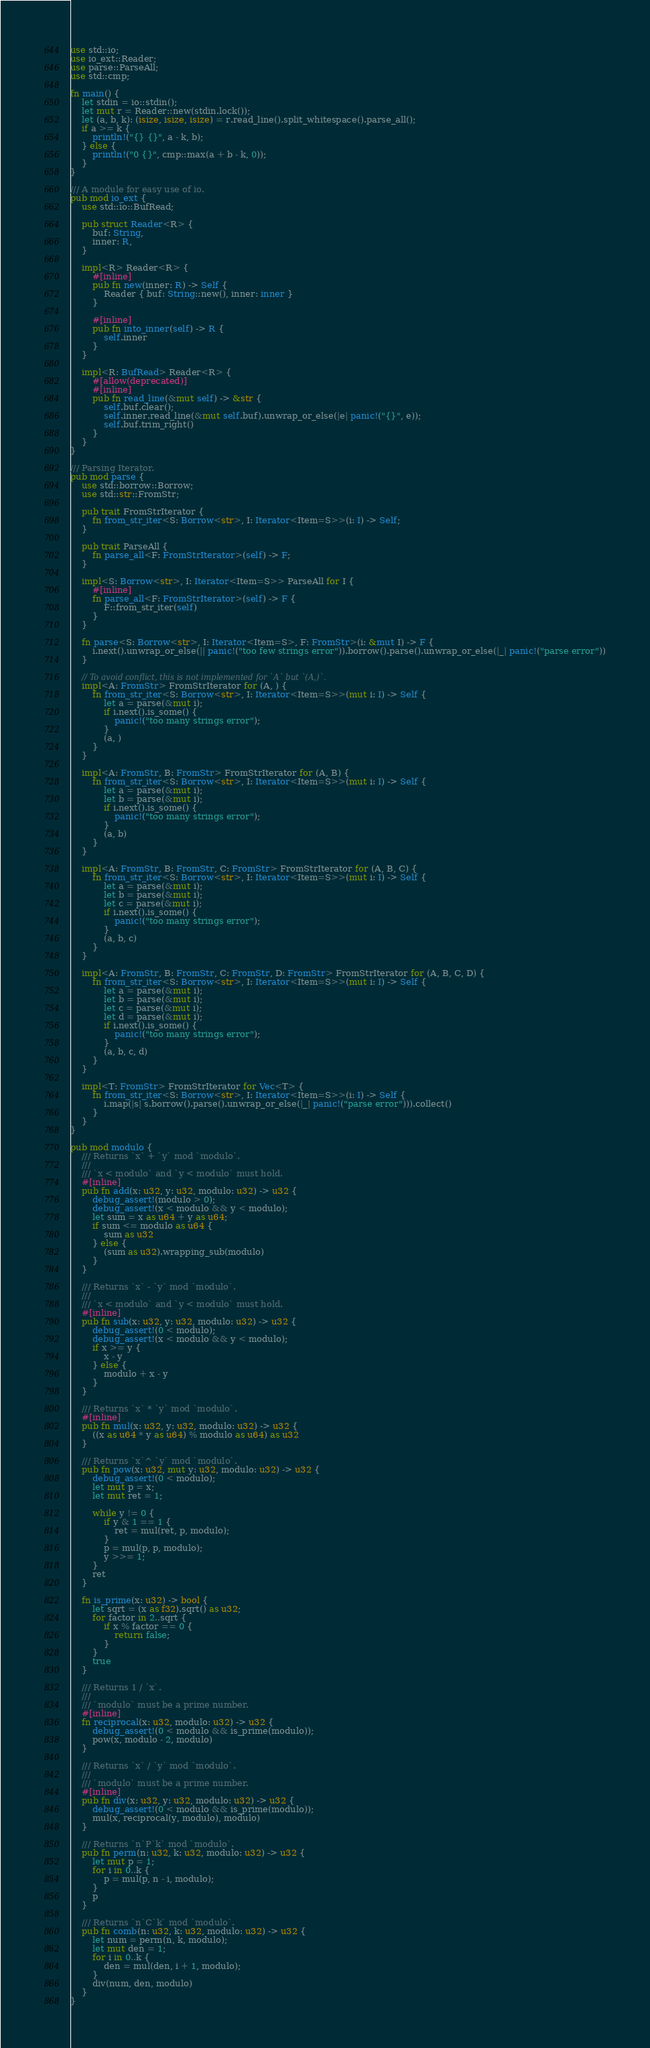Convert code to text. <code><loc_0><loc_0><loc_500><loc_500><_Rust_>use std::io;
use io_ext::Reader;
use parse::ParseAll;
use std::cmp;

fn main() {
    let stdin = io::stdin();
    let mut r = Reader::new(stdin.lock());
    let (a, b, k): (isize, isize, isize) = r.read_line().split_whitespace().parse_all();
    if a >= k {
        println!("{} {}", a - k, b);
    } else {
        println!("0 {}", cmp::max(a + b - k, 0));
    }
}

/// A module for easy use of io.
pub mod io_ext {
    use std::io::BufRead;

    pub struct Reader<R> {
        buf: String,
        inner: R,
    }

    impl<R> Reader<R> {
        #[inline]
        pub fn new(inner: R) -> Self {
            Reader { buf: String::new(), inner: inner }
        }

        #[inline]
        pub fn into_inner(self) -> R {
            self.inner
        }
    }

    impl<R: BufRead> Reader<R> {
        #[allow(deprecated)]
        #[inline]
        pub fn read_line(&mut self) -> &str {
            self.buf.clear();
            self.inner.read_line(&mut self.buf).unwrap_or_else(|e| panic!("{}", e));
            self.buf.trim_right()
        }
    }
}

/// Parsing Iterator.
pub mod parse {
    use std::borrow::Borrow;
    use std::str::FromStr;

    pub trait FromStrIterator {
        fn from_str_iter<S: Borrow<str>, I: Iterator<Item=S>>(i: I) -> Self;
    }

    pub trait ParseAll {
        fn parse_all<F: FromStrIterator>(self) -> F;
    }

    impl<S: Borrow<str>, I: Iterator<Item=S>> ParseAll for I {
        #[inline]
        fn parse_all<F: FromStrIterator>(self) -> F {
            F::from_str_iter(self)
        }
    }

    fn parse<S: Borrow<str>, I: Iterator<Item=S>, F: FromStr>(i: &mut I) -> F {
        i.next().unwrap_or_else(|| panic!("too few strings error")).borrow().parse().unwrap_or_else(|_| panic!("parse error"))
    }

    // To avoid conflict, this is not implemented for `A` but `(A,)`.
    impl<A: FromStr> FromStrIterator for (A, ) {
        fn from_str_iter<S: Borrow<str>, I: Iterator<Item=S>>(mut i: I) -> Self {
            let a = parse(&mut i);
            if i.next().is_some() {
                panic!("too many strings error");
            }
            (a, )
        }
    }

    impl<A: FromStr, B: FromStr> FromStrIterator for (A, B) {
        fn from_str_iter<S: Borrow<str>, I: Iterator<Item=S>>(mut i: I) -> Self {
            let a = parse(&mut i);
            let b = parse(&mut i);
            if i.next().is_some() {
                panic!("too many strings error");
            }
            (a, b)
        }
    }

    impl<A: FromStr, B: FromStr, C: FromStr> FromStrIterator for (A, B, C) {
        fn from_str_iter<S: Borrow<str>, I: Iterator<Item=S>>(mut i: I) -> Self {
            let a = parse(&mut i);
            let b = parse(&mut i);
            let c = parse(&mut i);
            if i.next().is_some() {
                panic!("too many strings error");
            }
            (a, b, c)
        }
    }

    impl<A: FromStr, B: FromStr, C: FromStr, D: FromStr> FromStrIterator for (A, B, C, D) {
        fn from_str_iter<S: Borrow<str>, I: Iterator<Item=S>>(mut i: I) -> Self {
            let a = parse(&mut i);
            let b = parse(&mut i);
            let c = parse(&mut i);
            let d = parse(&mut i);
            if i.next().is_some() {
                panic!("too many strings error");
            }
            (a, b, c, d)
        }
    }

    impl<T: FromStr> FromStrIterator for Vec<T> {
        fn from_str_iter<S: Borrow<str>, I: Iterator<Item=S>>(i: I) -> Self {
            i.map(|s| s.borrow().parse().unwrap_or_else(|_| panic!("parse error"))).collect()
        }
    }
}

pub mod modulo {
    /// Returns `x` + `y` mod `modulo`.
    ///
    /// `x < modulo` and `y < modulo` must hold.
    #[inline]
    pub fn add(x: u32, y: u32, modulo: u32) -> u32 {
        debug_assert!(modulo > 0);
        debug_assert!(x < modulo && y < modulo);
        let sum = x as u64 + y as u64;
        if sum <= modulo as u64 {
            sum as u32
        } else {
            (sum as u32).wrapping_sub(modulo)
        }
    }

    /// Returns `x` - `y` mod `modulo`.
    ///
    /// `x < modulo` and `y < modulo` must hold.
    #[inline]
    pub fn sub(x: u32, y: u32, modulo: u32) -> u32 {
        debug_assert!(0 < modulo);
        debug_assert!(x < modulo && y < modulo);
        if x >= y {
            x - y
        } else {
            modulo + x - y
        }
    }

    /// Returns `x` * `y` mod `modulo`.
    #[inline]
    pub fn mul(x: u32, y: u32, modulo: u32) -> u32 {
        ((x as u64 * y as u64) % modulo as u64) as u32
    }

    /// Returns `x`^ `y` mod `modulo`.
    pub fn pow(x: u32, mut y: u32, modulo: u32) -> u32 {
        debug_assert!(0 < modulo);
        let mut p = x;
        let mut ret = 1;

        while y != 0 {
            if y & 1 == 1 {
                ret = mul(ret, p, modulo);
            }
            p = mul(p, p, modulo);
            y >>= 1;
        }
        ret
    }

    fn is_prime(x: u32) -> bool {
        let sqrt = (x as f32).sqrt() as u32;
        for factor in 2..sqrt {
            if x % factor == 0 {
                return false;
            }
        }
        true
    }

    /// Returns 1 / `x`.
    ///
    /// `modulo` must be a prime number.
    #[inline]
    fn reciprocal(x: u32, modulo: u32) -> u32 {
        debug_assert!(0 < modulo && is_prime(modulo));
        pow(x, modulo - 2, modulo)
    }

    /// Returns `x` / `y` mod `modulo`.
    ///
    /// `modulo` must be a prime number.
    #[inline]
    pub fn div(x: u32, y: u32, modulo: u32) -> u32 {
        debug_assert!(0 < modulo && is_prime(modulo));
        mul(x, reciprocal(y, modulo), modulo)
    }

    /// Returns `n`P`k` mod `modulo`.
    pub fn perm(n: u32, k: u32, modulo: u32) -> u32 {
        let mut p = 1;
        for i in 0..k {
            p = mul(p, n - i, modulo);
        }
        p
    }

    /// Returns `n`C`k` mod `modulo`.
    pub fn comb(n: u32, k: u32, modulo: u32) -> u32 {
        let num = perm(n, k, modulo);
        let mut den = 1;
        for i in 0..k {
            den = mul(den, i + 1, modulo);
        }
        div(num, den, modulo)
    }
}</code> 